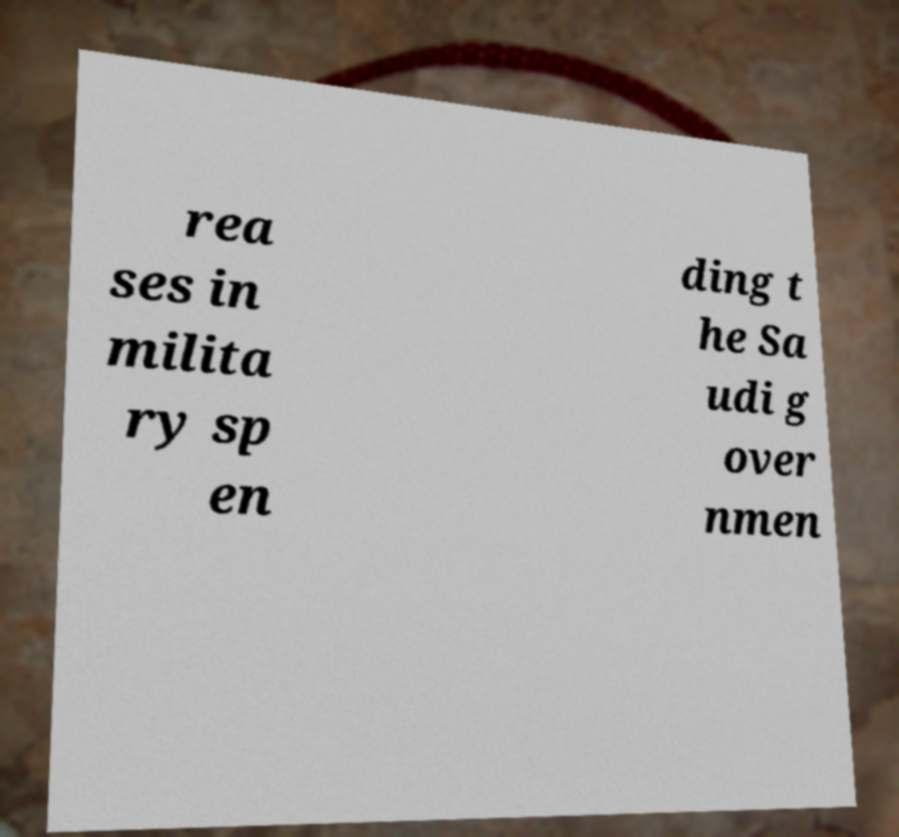Can you accurately transcribe the text from the provided image for me? rea ses in milita ry sp en ding t he Sa udi g over nmen 